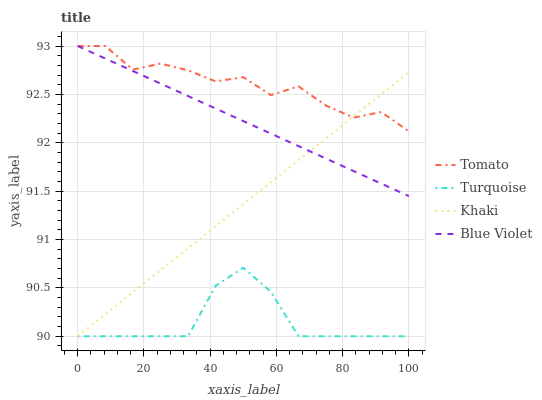Does Turquoise have the minimum area under the curve?
Answer yes or no. Yes. Does Tomato have the maximum area under the curve?
Answer yes or no. Yes. Does Khaki have the minimum area under the curve?
Answer yes or no. No. Does Khaki have the maximum area under the curve?
Answer yes or no. No. Is Blue Violet the smoothest?
Answer yes or no. Yes. Is Tomato the roughest?
Answer yes or no. Yes. Is Turquoise the smoothest?
Answer yes or no. No. Is Turquoise the roughest?
Answer yes or no. No. Does Turquoise have the lowest value?
Answer yes or no. Yes. Does Blue Violet have the lowest value?
Answer yes or no. No. Does Blue Violet have the highest value?
Answer yes or no. Yes. Does Khaki have the highest value?
Answer yes or no. No. Is Turquoise less than Blue Violet?
Answer yes or no. Yes. Is Blue Violet greater than Turquoise?
Answer yes or no. Yes. Does Blue Violet intersect Tomato?
Answer yes or no. Yes. Is Blue Violet less than Tomato?
Answer yes or no. No. Is Blue Violet greater than Tomato?
Answer yes or no. No. Does Turquoise intersect Blue Violet?
Answer yes or no. No. 